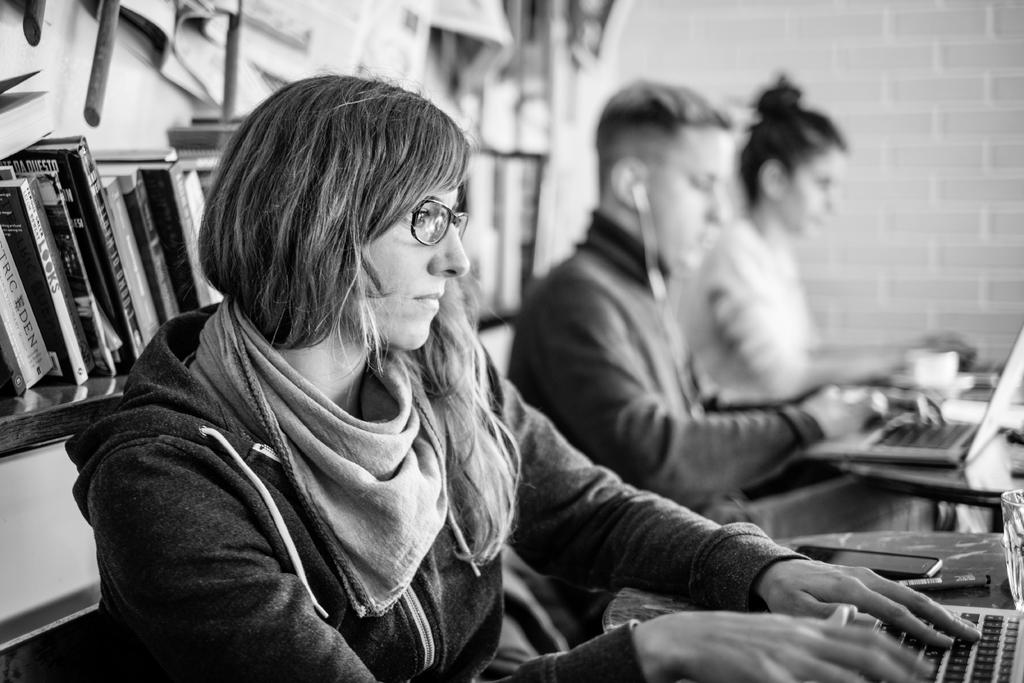<image>
Write a terse but informative summary of the picture. One of the books on a shelf behind people working online says "Looks" on the spine. 